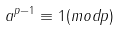Convert formula to latex. <formula><loc_0><loc_0><loc_500><loc_500>a ^ { p - 1 } \equiv 1 ( m o d p )</formula> 